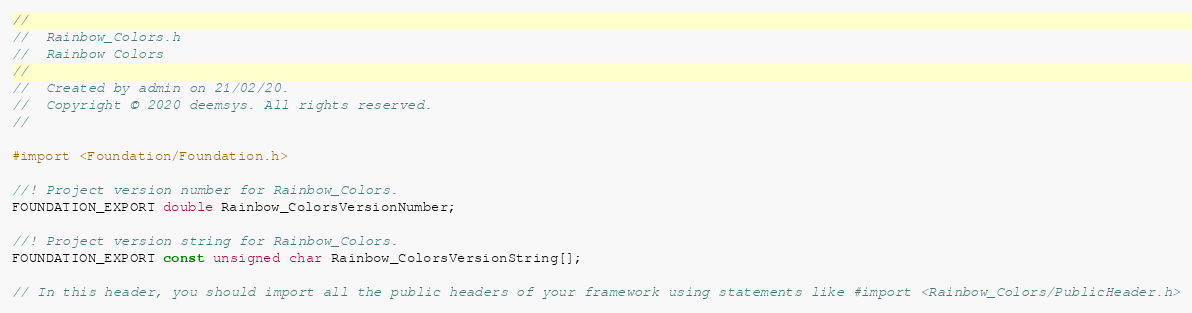<code> <loc_0><loc_0><loc_500><loc_500><_C_>//
//  Rainbow_Colors.h
//  Rainbow Colors
//
//  Created by admin on 21/02/20.
//  Copyright © 2020 deemsys. All rights reserved.
//

#import <Foundation/Foundation.h>

//! Project version number for Rainbow_Colors.
FOUNDATION_EXPORT double Rainbow_ColorsVersionNumber;

//! Project version string for Rainbow_Colors.
FOUNDATION_EXPORT const unsigned char Rainbow_ColorsVersionString[];

// In this header, you should import all the public headers of your framework using statements like #import <Rainbow_Colors/PublicHeader.h>


</code> 